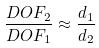<formula> <loc_0><loc_0><loc_500><loc_500>\frac { D O F _ { 2 } } { D O F _ { 1 } } \approx \frac { d _ { 1 } } { d _ { 2 } }</formula> 